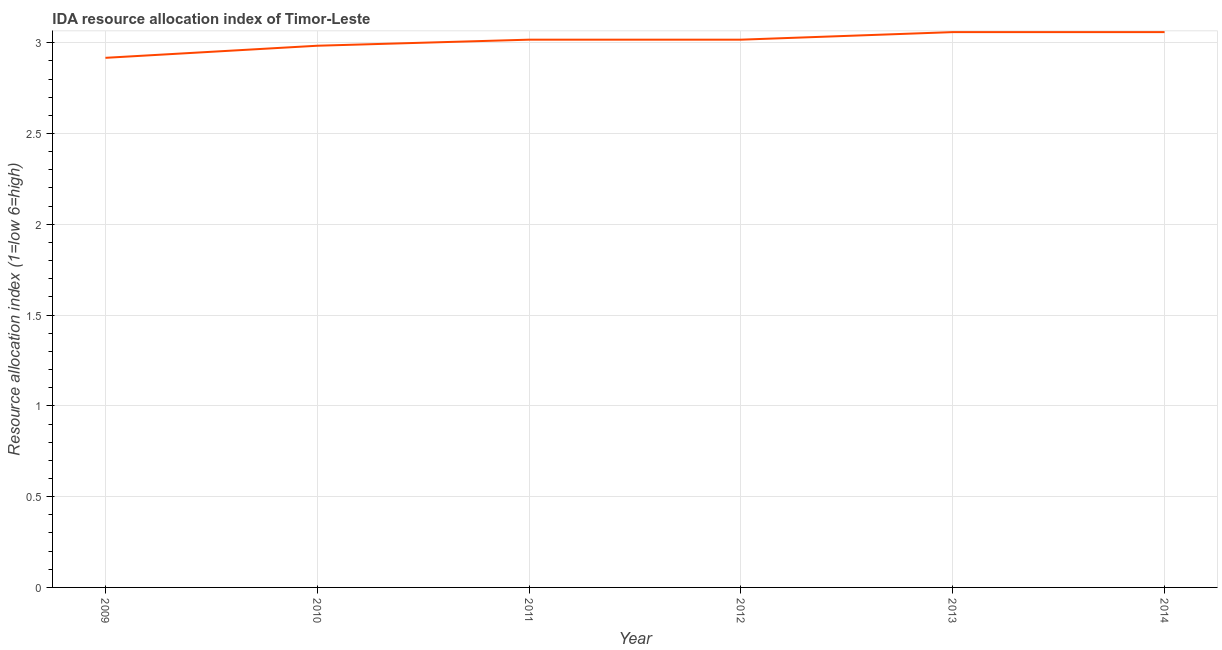What is the ida resource allocation index in 2010?
Keep it short and to the point. 2.98. Across all years, what is the maximum ida resource allocation index?
Give a very brief answer. 3.06. Across all years, what is the minimum ida resource allocation index?
Give a very brief answer. 2.92. What is the sum of the ida resource allocation index?
Make the answer very short. 18.05. What is the difference between the ida resource allocation index in 2009 and 2010?
Your answer should be very brief. -0.07. What is the average ida resource allocation index per year?
Your answer should be compact. 3.01. What is the median ida resource allocation index?
Give a very brief answer. 3.02. Do a majority of the years between 2013 and 2012 (inclusive) have ida resource allocation index greater than 2.7 ?
Give a very brief answer. No. What is the ratio of the ida resource allocation index in 2009 to that in 2012?
Your answer should be compact. 0.97. Is the difference between the ida resource allocation index in 2011 and 2012 greater than the difference between any two years?
Your answer should be compact. No. What is the difference between the highest and the second highest ida resource allocation index?
Ensure brevity in your answer.  3.333333329802457e-6. Is the sum of the ida resource allocation index in 2011 and 2013 greater than the maximum ida resource allocation index across all years?
Keep it short and to the point. Yes. What is the difference between the highest and the lowest ida resource allocation index?
Offer a very short reply. 0.14. In how many years, is the ida resource allocation index greater than the average ida resource allocation index taken over all years?
Your answer should be very brief. 4. Does the ida resource allocation index monotonically increase over the years?
Your response must be concise. No. What is the difference between two consecutive major ticks on the Y-axis?
Your response must be concise. 0.5. Does the graph contain any zero values?
Your answer should be very brief. No. What is the title of the graph?
Provide a short and direct response. IDA resource allocation index of Timor-Leste. What is the label or title of the X-axis?
Keep it short and to the point. Year. What is the label or title of the Y-axis?
Your response must be concise. Resource allocation index (1=low 6=high). What is the Resource allocation index (1=low 6=high) in 2009?
Your answer should be compact. 2.92. What is the Resource allocation index (1=low 6=high) of 2010?
Offer a terse response. 2.98. What is the Resource allocation index (1=low 6=high) in 2011?
Offer a terse response. 3.02. What is the Resource allocation index (1=low 6=high) of 2012?
Your response must be concise. 3.02. What is the Resource allocation index (1=low 6=high) of 2013?
Give a very brief answer. 3.06. What is the Resource allocation index (1=low 6=high) in 2014?
Provide a short and direct response. 3.06. What is the difference between the Resource allocation index (1=low 6=high) in 2009 and 2010?
Keep it short and to the point. -0.07. What is the difference between the Resource allocation index (1=low 6=high) in 2009 and 2013?
Offer a terse response. -0.14. What is the difference between the Resource allocation index (1=low 6=high) in 2009 and 2014?
Give a very brief answer. -0.14. What is the difference between the Resource allocation index (1=low 6=high) in 2010 and 2011?
Make the answer very short. -0.03. What is the difference between the Resource allocation index (1=low 6=high) in 2010 and 2012?
Give a very brief answer. -0.03. What is the difference between the Resource allocation index (1=low 6=high) in 2010 and 2013?
Provide a short and direct response. -0.07. What is the difference between the Resource allocation index (1=low 6=high) in 2010 and 2014?
Give a very brief answer. -0.07. What is the difference between the Resource allocation index (1=low 6=high) in 2011 and 2012?
Offer a very short reply. 0. What is the difference between the Resource allocation index (1=low 6=high) in 2011 and 2013?
Your answer should be very brief. -0.04. What is the difference between the Resource allocation index (1=low 6=high) in 2011 and 2014?
Ensure brevity in your answer.  -0.04. What is the difference between the Resource allocation index (1=low 6=high) in 2012 and 2013?
Provide a succinct answer. -0.04. What is the difference between the Resource allocation index (1=low 6=high) in 2012 and 2014?
Provide a short and direct response. -0.04. What is the ratio of the Resource allocation index (1=low 6=high) in 2009 to that in 2012?
Provide a succinct answer. 0.97. What is the ratio of the Resource allocation index (1=low 6=high) in 2009 to that in 2013?
Give a very brief answer. 0.95. What is the ratio of the Resource allocation index (1=low 6=high) in 2009 to that in 2014?
Keep it short and to the point. 0.95. What is the ratio of the Resource allocation index (1=low 6=high) in 2012 to that in 2014?
Provide a succinct answer. 0.99. What is the ratio of the Resource allocation index (1=low 6=high) in 2013 to that in 2014?
Your answer should be compact. 1. 